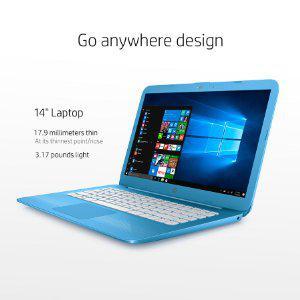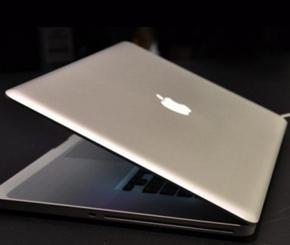The first image is the image on the left, the second image is the image on the right. For the images displayed, is the sentence "All laptops are at least partly open, but only one laptop is displayed with its screen visible." factually correct? Answer yes or no. Yes. The first image is the image on the left, the second image is the image on the right. Considering the images on both sides, is "There is only one laptop screen visible out of two laptops." valid? Answer yes or no. Yes. 